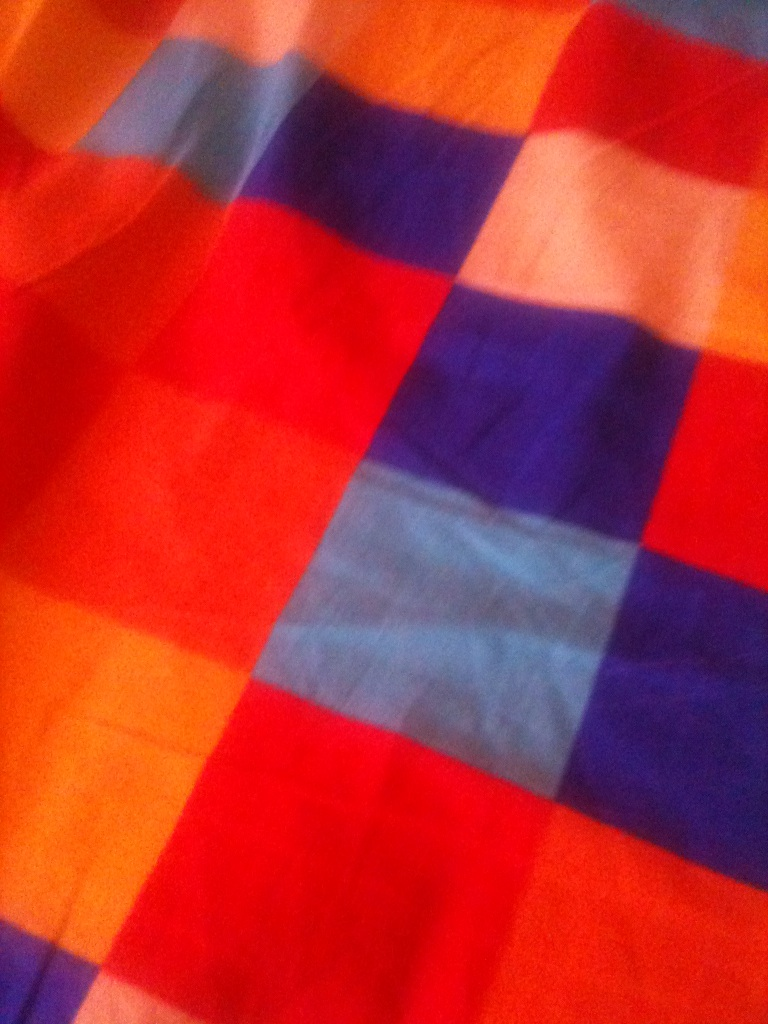How might this fabric inspire someone in their daily life? Looking at this vibrant and beautifully patterned fabric can inspire creativity and positivity in one's daily life. Its lively colors might encourage someone to start a new artistic project or add more color to their surroundings. The cheerful and energetic feel of the fabric could also serve as a reminder to find joy in the small things and to embrace the richness of everyday experiences. For fashion enthusiasts, it might spark ideas for putting together bold and stylish outfits that reflect their personality. 